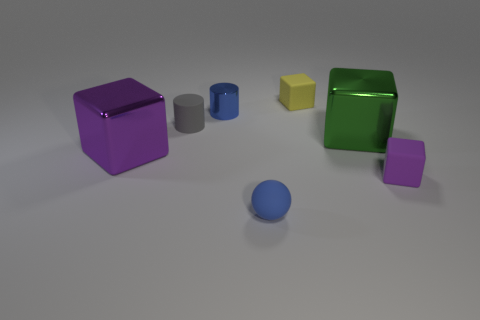What number of big objects are either green blocks or purple shiny blocks?
Provide a succinct answer. 2. The gray thing is what size?
Make the answer very short. Small. There is a sphere; does it have the same size as the metal cube that is on the left side of the small yellow matte object?
Ensure brevity in your answer.  No. What number of red objects are either small blocks or matte objects?
Give a very brief answer. 0. How many big objects are there?
Keep it short and to the point. 2. There is a blue object behind the tiny blue matte object; what size is it?
Provide a short and direct response. Small. Is the blue rubber thing the same size as the green shiny block?
Your response must be concise. No. What number of things are tiny blue objects or tiny matte blocks that are behind the shiny cylinder?
Give a very brief answer. 3. What material is the green object?
Make the answer very short. Metal. Is there anything else that is the same color as the matte sphere?
Give a very brief answer. Yes. 